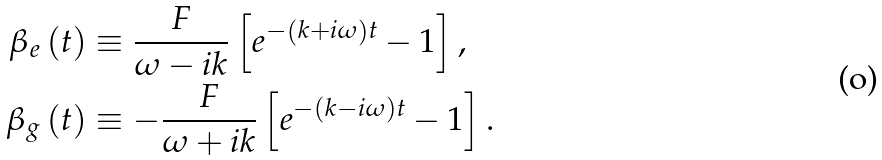<formula> <loc_0><loc_0><loc_500><loc_500>\beta _ { e } \left ( t \right ) & \equiv \frac { F } { \omega - i k } \left [ e ^ { - \left ( k + i \omega \right ) t } - 1 \right ] , \\ \beta _ { g } \left ( t \right ) & \equiv - \frac { F } { \omega + i k } \left [ e ^ { - \left ( k - i \omega \right ) t } - 1 \right ] .</formula> 